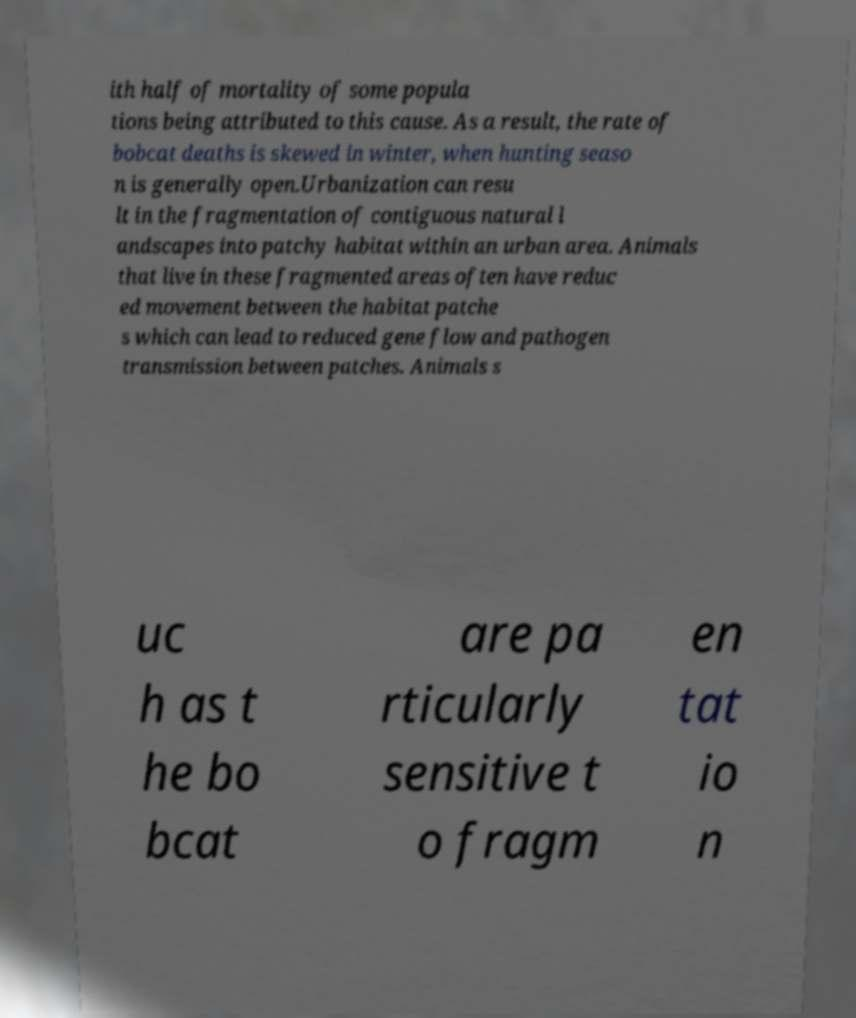Can you accurately transcribe the text from the provided image for me? ith half of mortality of some popula tions being attributed to this cause. As a result, the rate of bobcat deaths is skewed in winter, when hunting seaso n is generally open.Urbanization can resu lt in the fragmentation of contiguous natural l andscapes into patchy habitat within an urban area. Animals that live in these fragmented areas often have reduc ed movement between the habitat patche s which can lead to reduced gene flow and pathogen transmission between patches. Animals s uc h as t he bo bcat are pa rticularly sensitive t o fragm en tat io n 